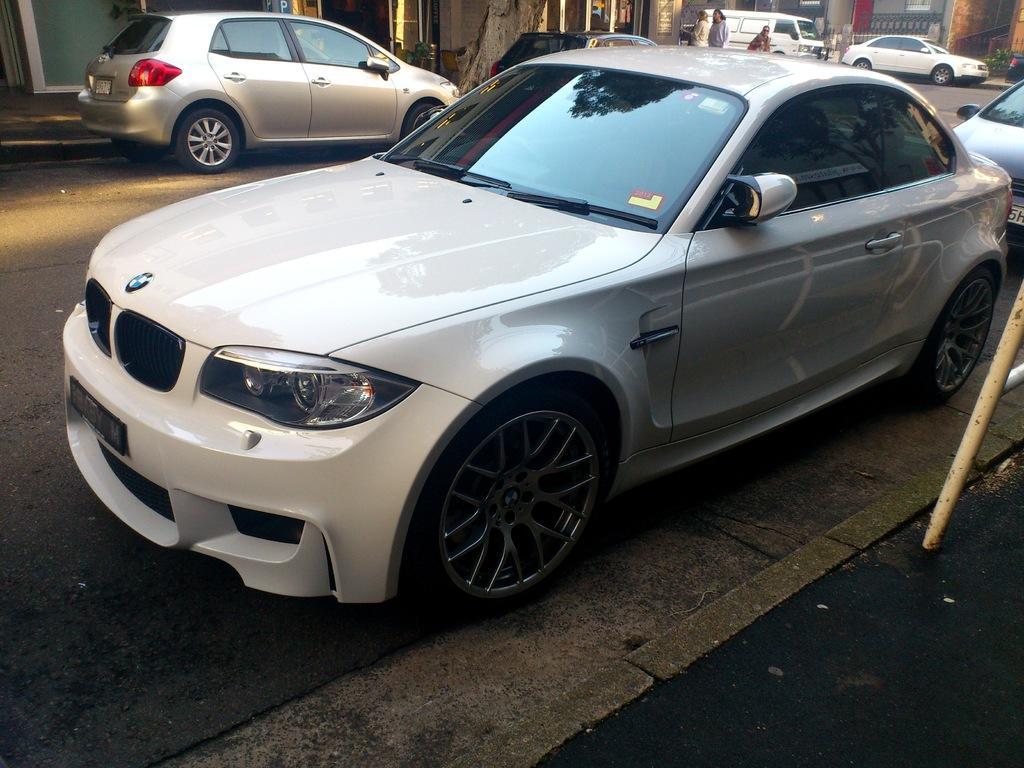Describe this image in one or two sentences. In the picture we can see a path beside it, we can see a car is parked on the road which is white in color and behind it, we can also see another car and to the opposite side, we can see some cars are parked near the building and in the background also we can see some cars are parked and near to it we can see some people are standing. 